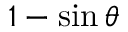<formula> <loc_0><loc_0><loc_500><loc_500>1 - \sin \theta</formula> 